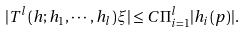<formula> <loc_0><loc_0><loc_500><loc_500>| T ^ { l } ( h ; h _ { 1 } , \cdots , h _ { l } ) \xi | \leq C \Pi _ { i = 1 } ^ { l } | h _ { i } ( p ) | .</formula> 